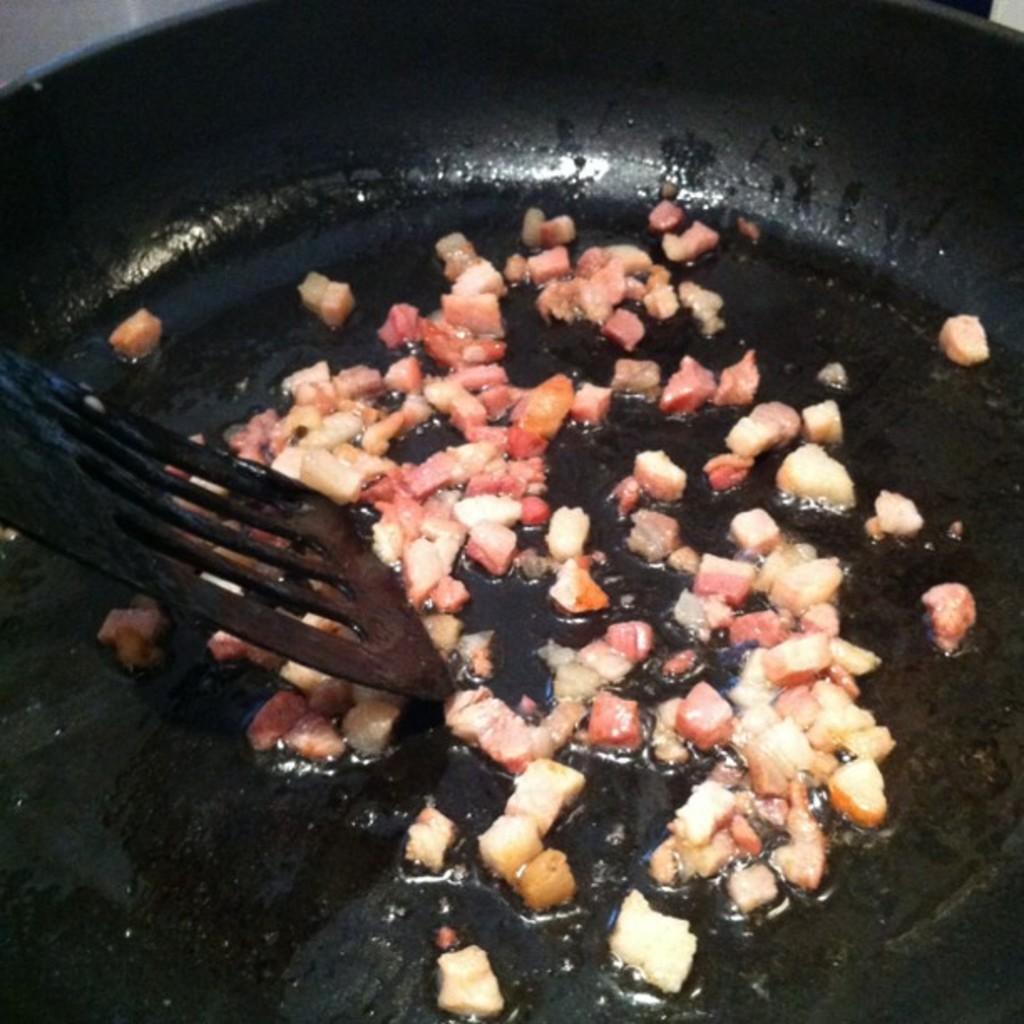Could you give a brief overview of what you see in this image? In this image I see the frying pan which is of black in color and I see an utensil which is of black in color and I see pieces of food which is of white and red in color. 